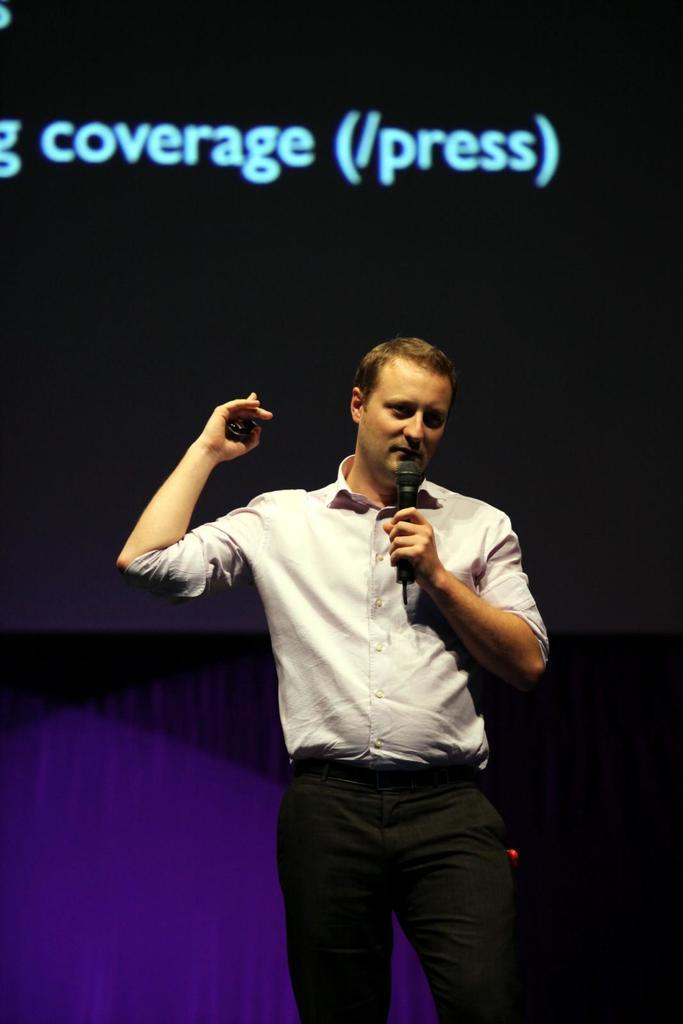Who is present in the image? There is a man in the image. What is the man doing in the image? The man is standing in the image. What object is the man holding in the image? The man is holding a microphone in the image. What can be seen in the background of the image? There is a screen in the background of the image. What type of pet can be seen sitting on the man's shoulder in the image? There is no pet present on the man's shoulder in the image. What store is visible in the background of the image? There is no store visible in the background of the image; only a screen can be seen. 